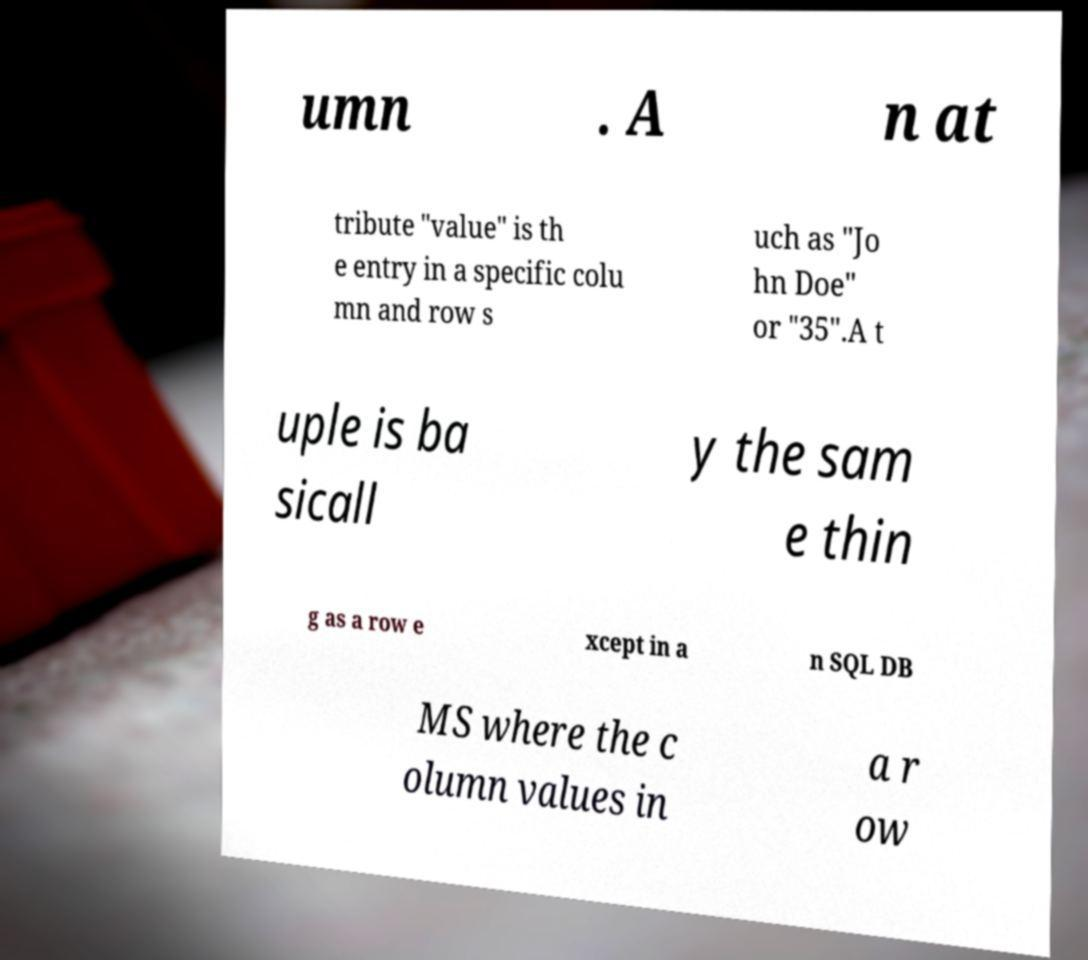For documentation purposes, I need the text within this image transcribed. Could you provide that? umn . A n at tribute "value" is th e entry in a specific colu mn and row s uch as "Jo hn Doe" or "35".A t uple is ba sicall y the sam e thin g as a row e xcept in a n SQL DB MS where the c olumn values in a r ow 